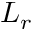<formula> <loc_0><loc_0><loc_500><loc_500>L _ { r }</formula> 